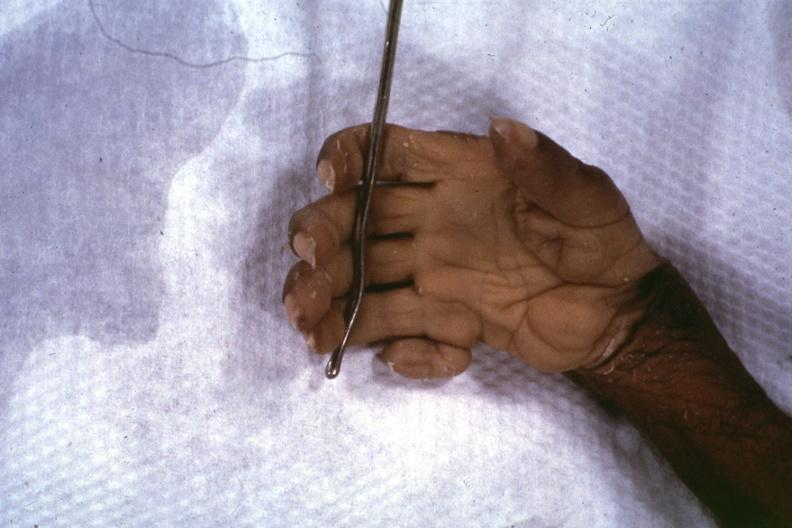what shows close-up supernumerary digit?
Answer the question using a single word or phrase. No 